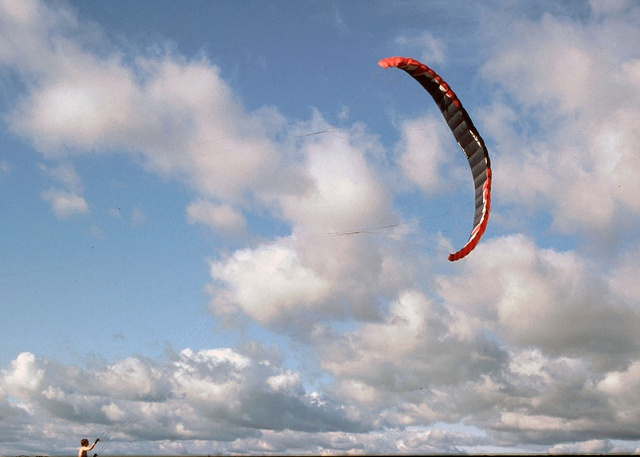Describe the objects in this image and their specific colors. I can see kite in darkgray, black, maroon, gray, and brown tones and people in darkgray, maroon, black, and tan tones in this image. 